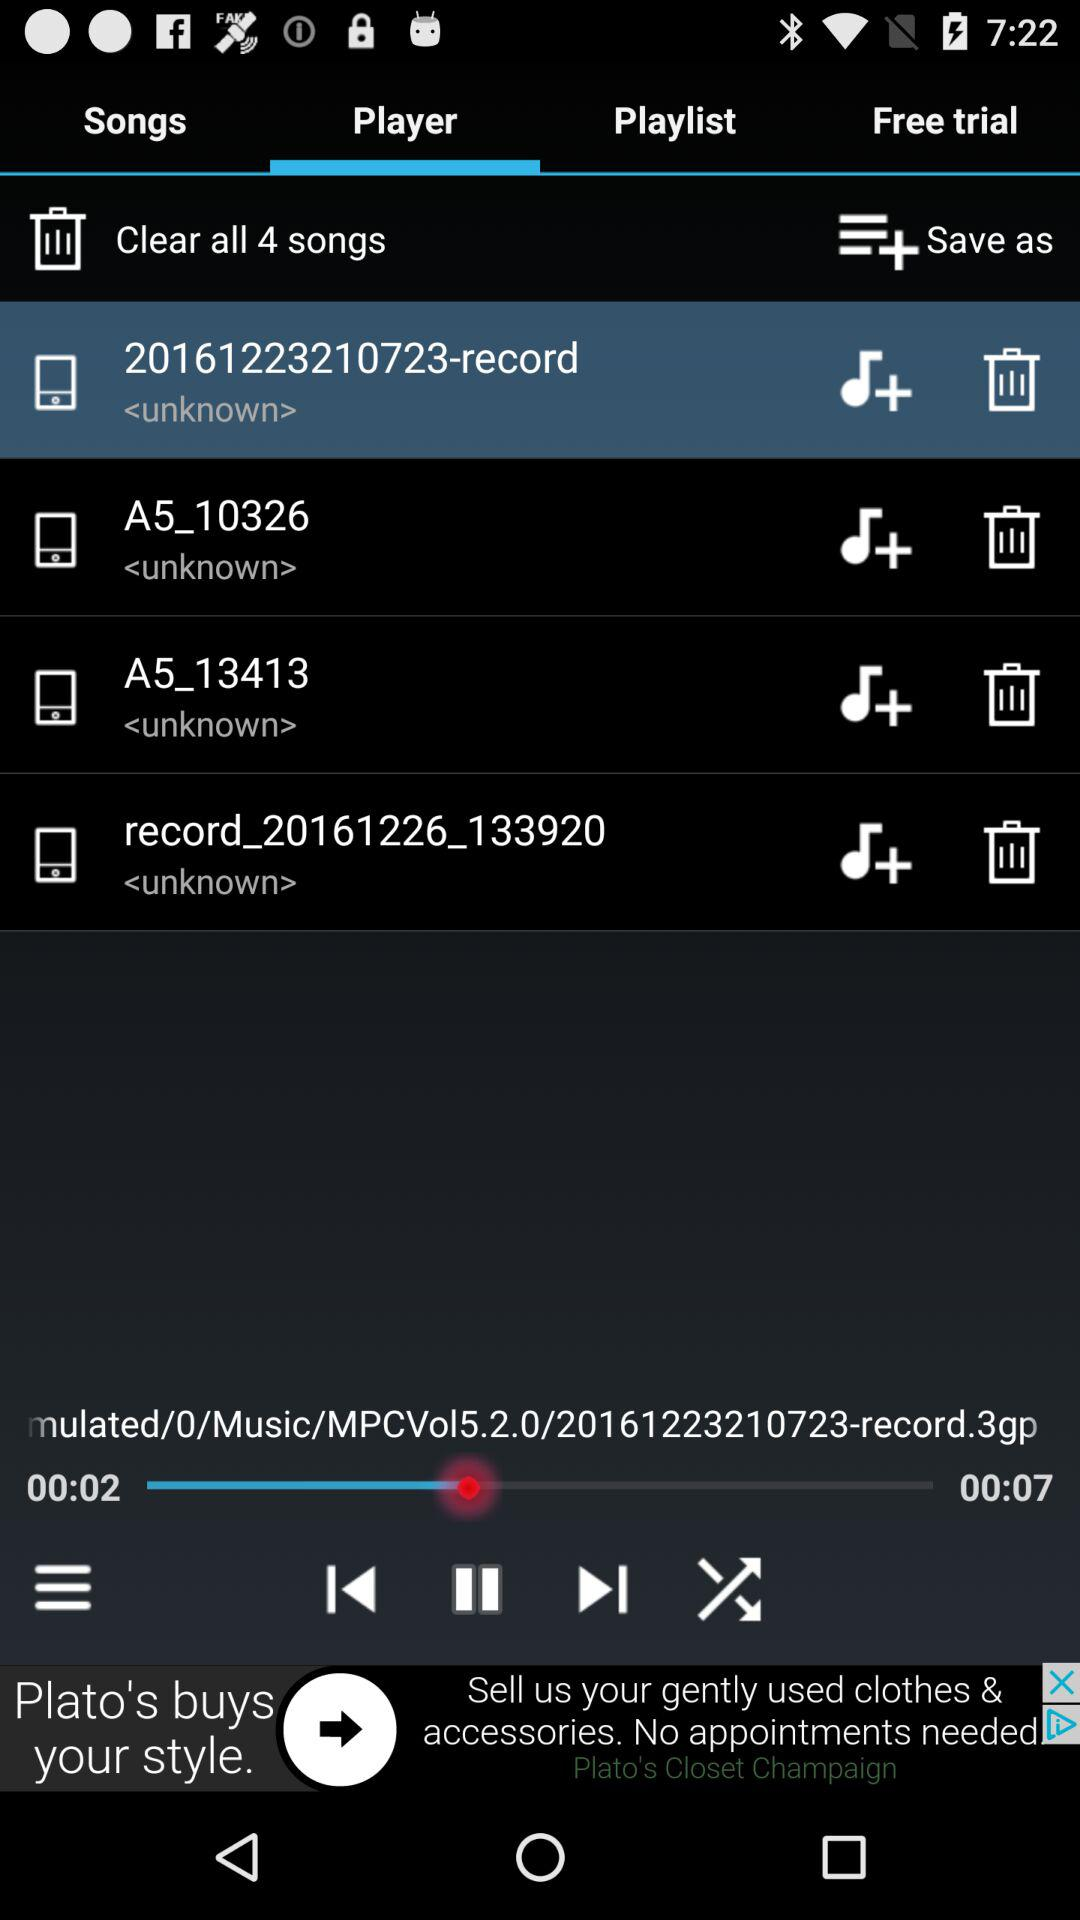How many songs can be cleared? There are 4 songs that can be cleared. 